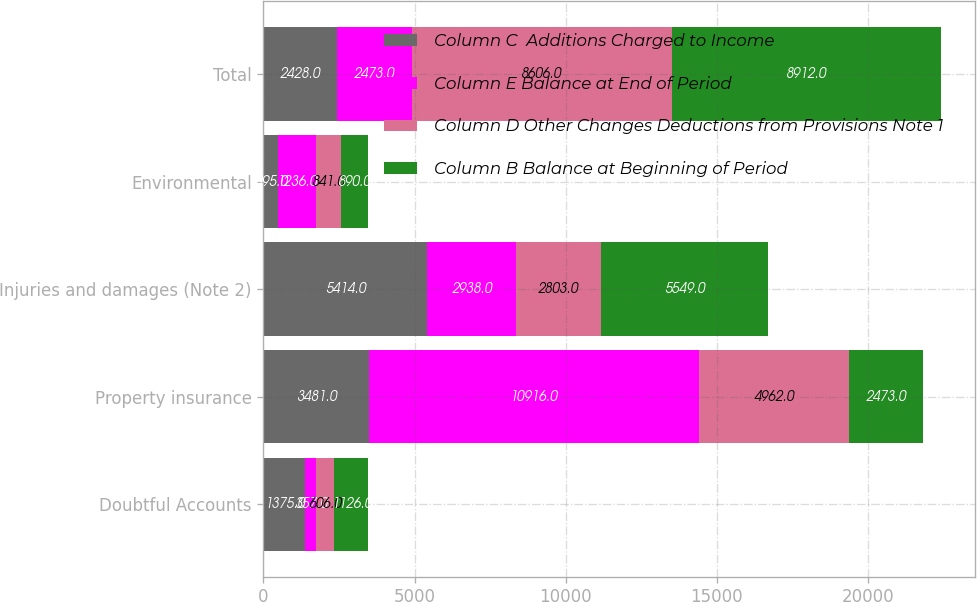Convert chart. <chart><loc_0><loc_0><loc_500><loc_500><stacked_bar_chart><ecel><fcel>Doubtful Accounts<fcel>Property insurance<fcel>Injuries and damages (Note 2)<fcel>Environmental<fcel>Total<nl><fcel>Column C  Additions Charged to Income<fcel>1375<fcel>3481<fcel>5414<fcel>495<fcel>2428<nl><fcel>Column E Balance at End of Period<fcel>357<fcel>10916<fcel>2938<fcel>1236<fcel>2473<nl><fcel>Column D Other Changes Deductions from Provisions Note 1<fcel>606<fcel>4962<fcel>2803<fcel>841<fcel>8606<nl><fcel>Column B Balance at Beginning of Period<fcel>1126<fcel>2473<fcel>5549<fcel>890<fcel>8912<nl></chart> 